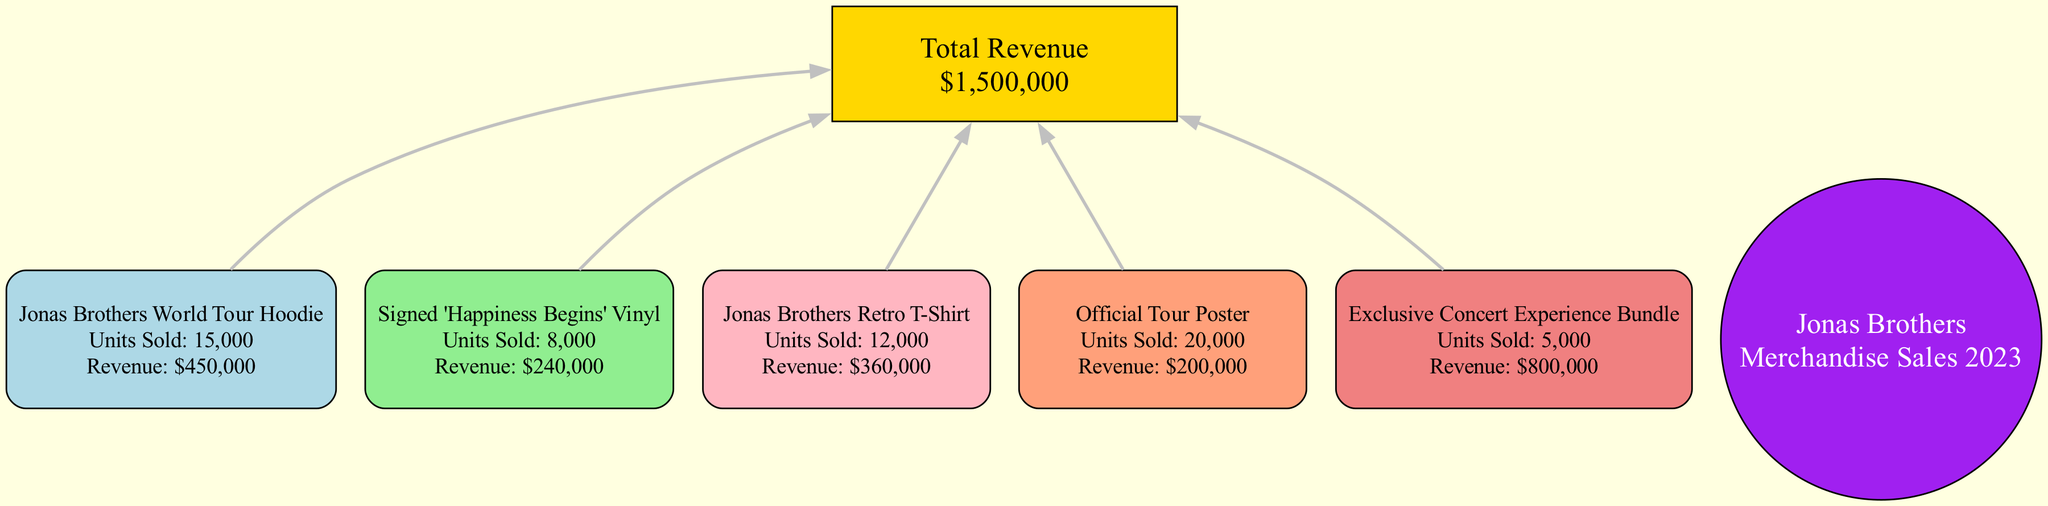What is the total revenue generated from merchandise sales in 2023? The diagram specifies the total revenue in the 'Total Revenue' node, which explicitly states "$1,500,000" as the total.
Answer: $1,500,000 How many units of the 'Jonas Brothers World Tour Hoodie' were sold? The diagram includes the specific details of each item, and for the 'Jonas Brothers World Tour Hoodie', it lists 'Units Sold: 15,000'.
Answer: 15,000 Which item generated the highest revenue? By examining the revenue figures in each item's data, the 'Exclusive Concert Experience Bundle' stands out with a revenue of $800,000, which is the highest amount in the list.
Answer: Exclusive Concert Experience Bundle How many popular items are shown in the diagram? The diagram lists five different popular items, which can be counted from the nodes representing each item.
Answer: 5 What is the revenue generated by 'Signed Happiness Begins Vinyl'? In the diagram, the revenue section for 'Signed Happiness Begins Vinyl' states 'Revenue: $240,000', providing the exact figure for that item.
Answer: $240,000 Which popular item sold the least units? By comparing the units sold for each item, the 'Exclusive Concert Experience Bundle' has the lowest figure with 5,000 units sold.
Answer: Exclusive Concert Experience Bundle What is the revenue generated from the 'Official Tour Poster'? The diagram shows that the revenue for the 'Official Tour Poster' is clearly indicated as 'Revenue: $200,000', allowing for a direct extraction of this information.
Answer: $200,000 How are the items related to the total revenue? The diagram illustrates that all five popular item nodes connect directly to the 'Total Revenue' node, indicating that their sales collectively contribute to the overall revenue figure.
Answer: They all connect to total revenue What color represents the 'Jonas Brothers Retro T-Shirt' in the diagram? The diagram indicates that 'Jonas Brothers Retro T-Shirt' is shown using a light pink color, which is the specific color assigned to that item's node.
Answer: Light pink 